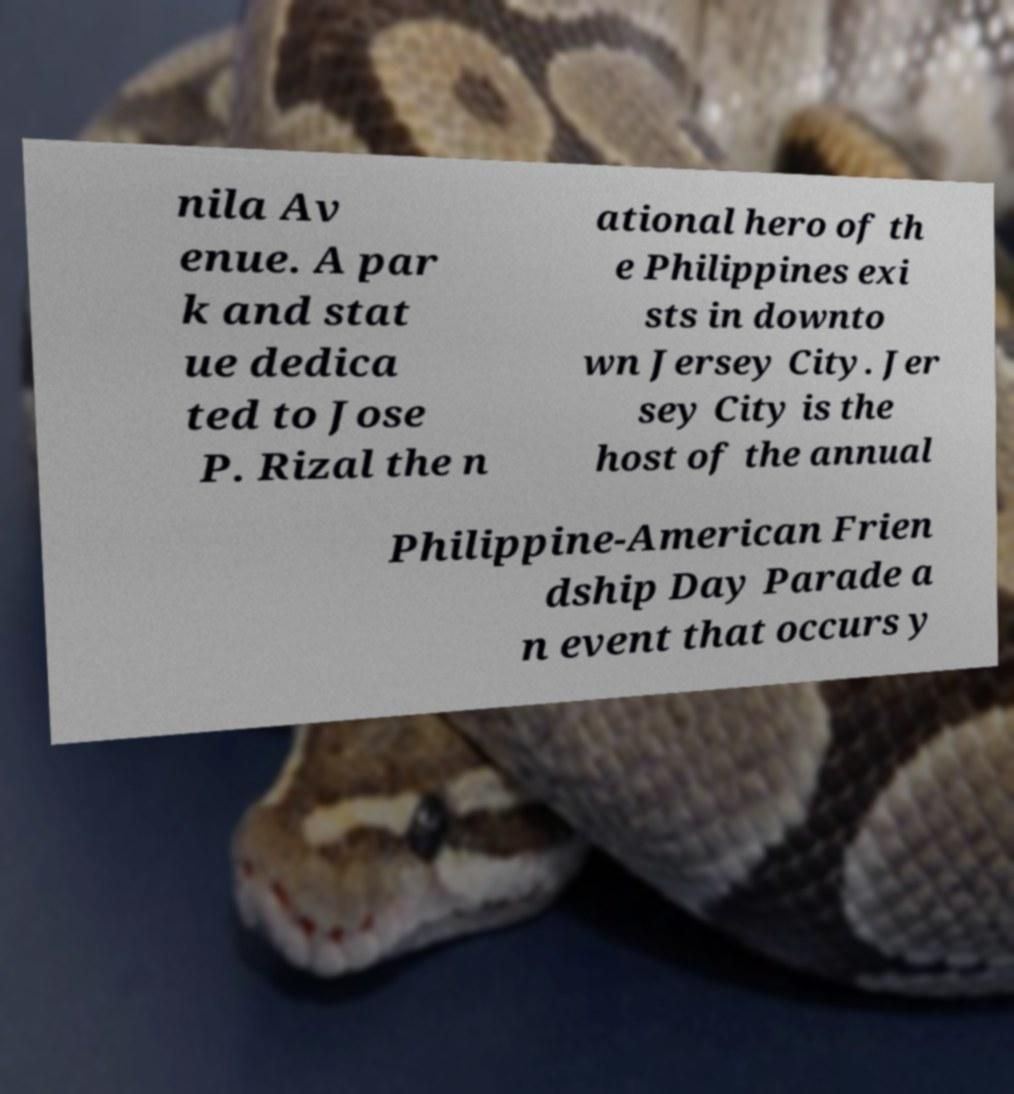Can you read and provide the text displayed in the image?This photo seems to have some interesting text. Can you extract and type it out for me? nila Av enue. A par k and stat ue dedica ted to Jose P. Rizal the n ational hero of th e Philippines exi sts in downto wn Jersey City. Jer sey City is the host of the annual Philippine-American Frien dship Day Parade a n event that occurs y 